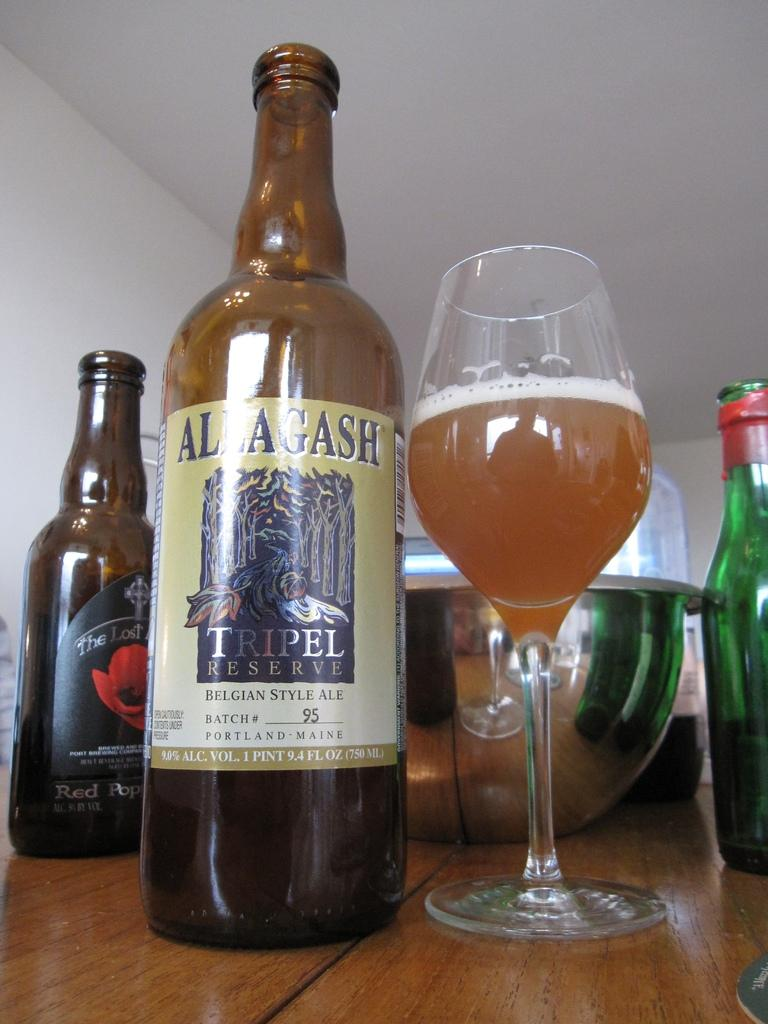<image>
Write a terse but informative summary of the picture. A bottle of Alagash Belgian style Ale and some other alcohol are on the table 